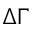<formula> <loc_0><loc_0><loc_500><loc_500>\Delta \Gamma</formula> 